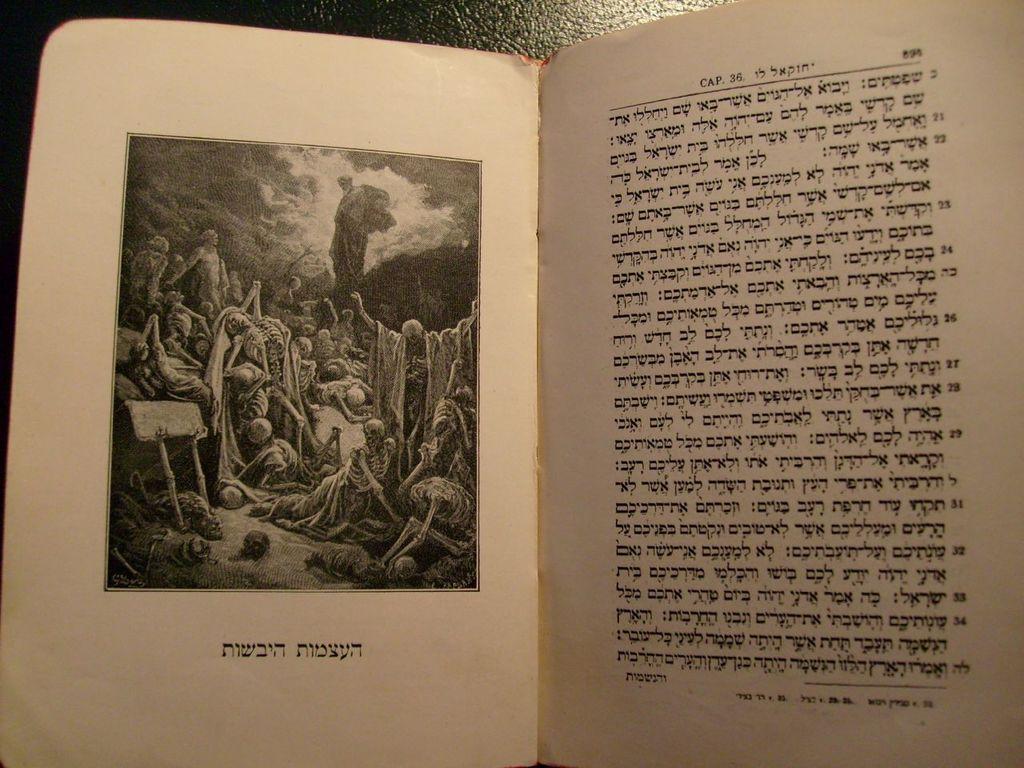What language is this?
Your response must be concise. Unanswerable. Whats the cap number?
Offer a very short reply. 36. 